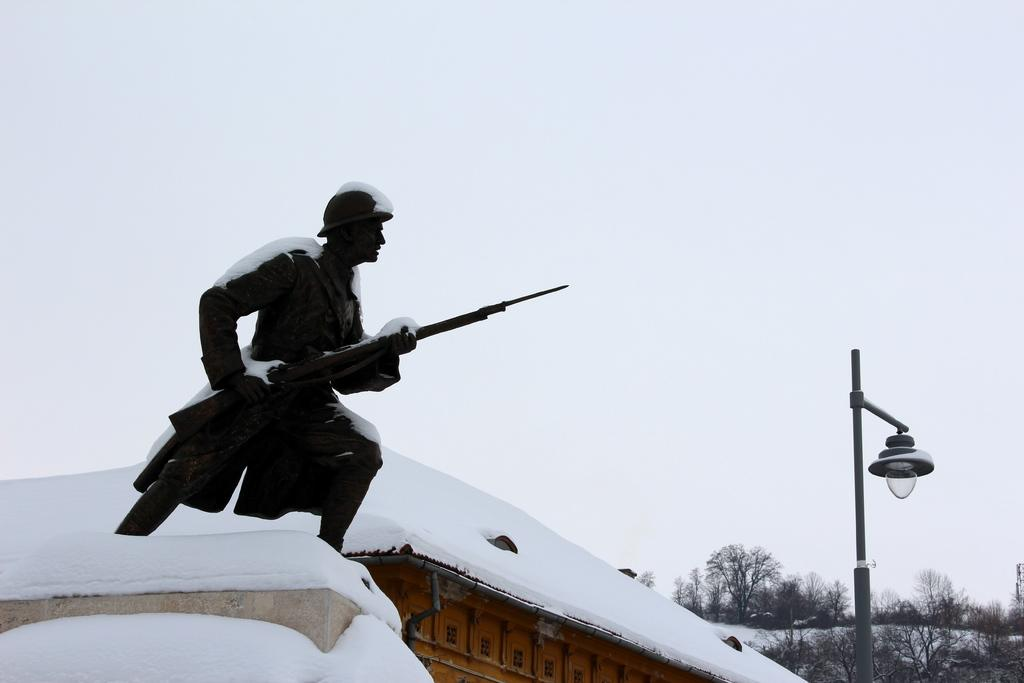What type of structure is present in the image? There is a house in the image. What weather condition is depicted in the image? There is snow in the image. What type of object can be seen in the image? There is a statue in the image. What type of lighting is present in the image? There is a street lamp in the image. What type of vegetation is visible in the image? There are trees in the image. What is visible at the top of the image? The sky is visible in the image. Where is the drain located in the image? There is no drain present in the image. What type of writing instrument is shown in the image? There is no pen present in the image. What type of material is the statue made of in the image? The provided facts do not mention the material of the statue, so we cannot definitively answer that question. What type of substance is being used to create a sculpture in the image? There is no wax or sculpture being created in the image. 